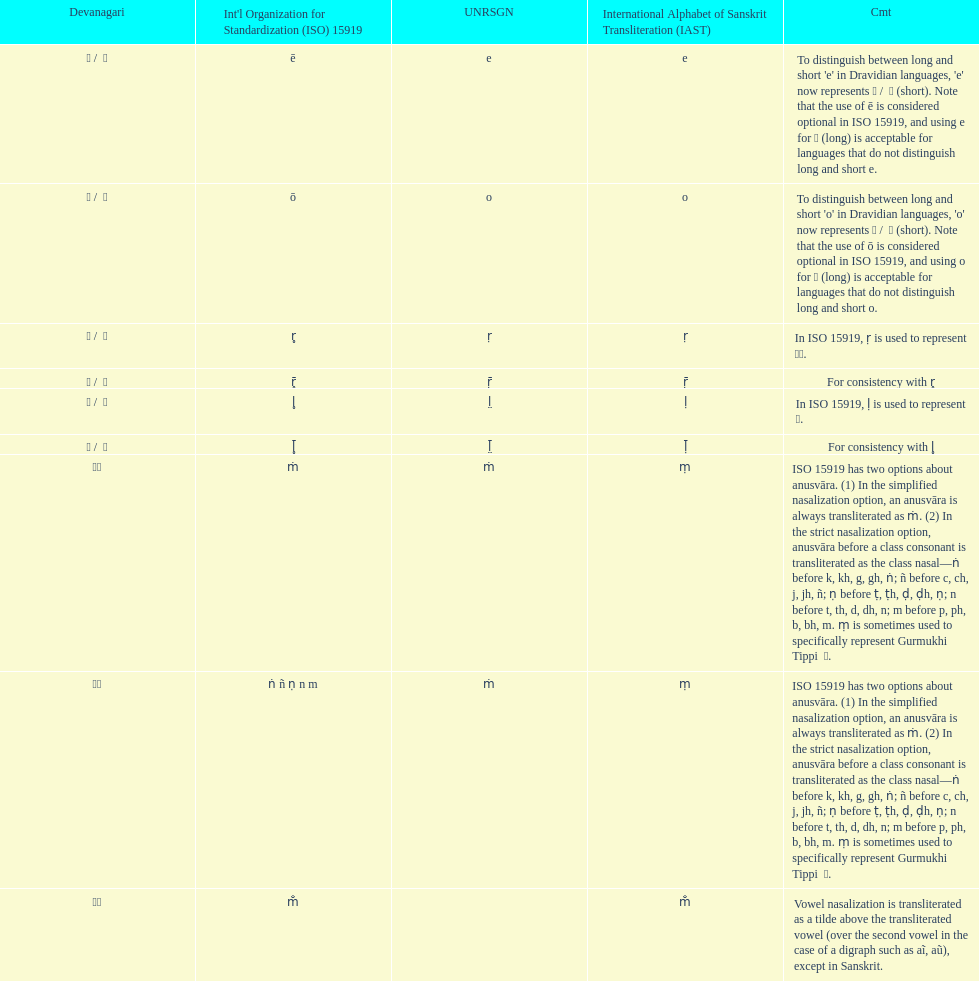This table shows the difference between how many transliterations? 3. 